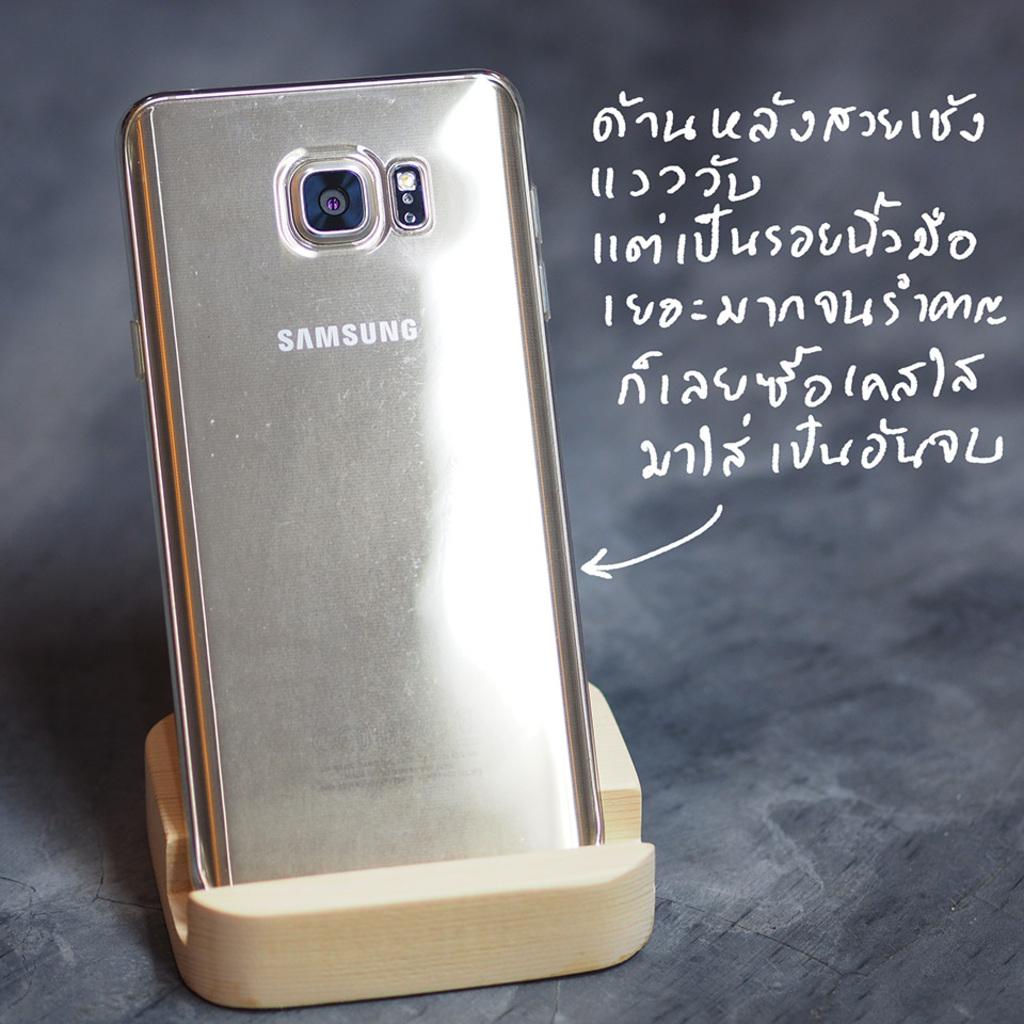What brand of phone is this?
Make the answer very short. Samsung. What brand of smartphone is this?
Make the answer very short. Samsung. 